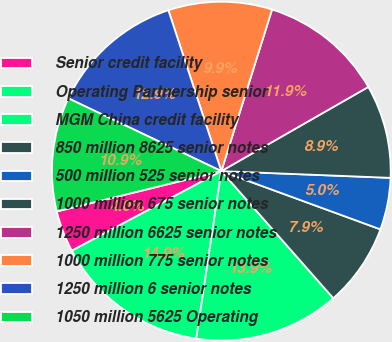Convert chart. <chart><loc_0><loc_0><loc_500><loc_500><pie_chart><fcel>Senior credit facility<fcel>Operating Partnership senior<fcel>MGM China credit facility<fcel>850 million 8625 senior notes<fcel>500 million 525 senior notes<fcel>1000 million 675 senior notes<fcel>1250 million 6625 senior notes<fcel>1000 million 775 senior notes<fcel>1250 million 6 senior notes<fcel>1050 million 5625 Operating<nl><fcel>3.96%<fcel>14.85%<fcel>13.86%<fcel>7.92%<fcel>4.95%<fcel>8.91%<fcel>11.88%<fcel>9.9%<fcel>12.87%<fcel>10.89%<nl></chart> 